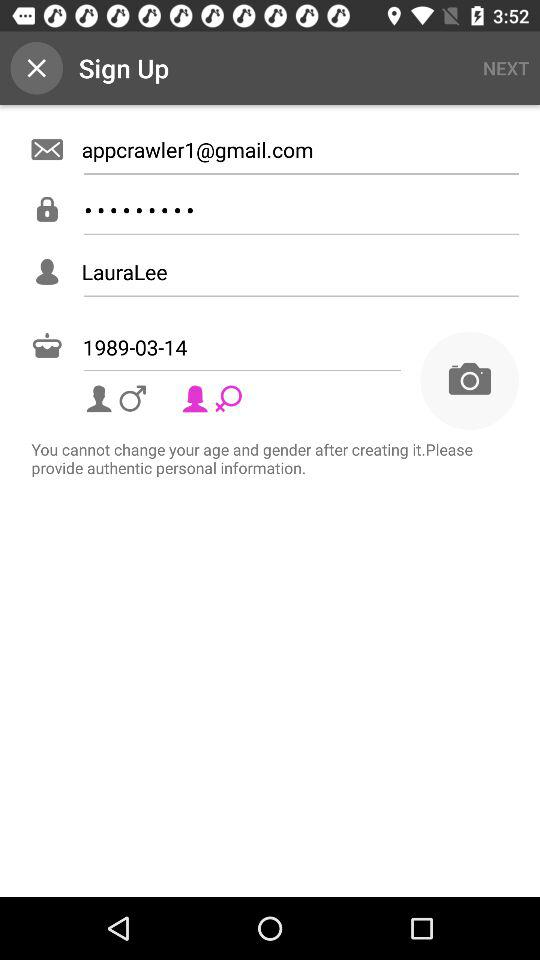What is the name? The name is "LauraLee". 